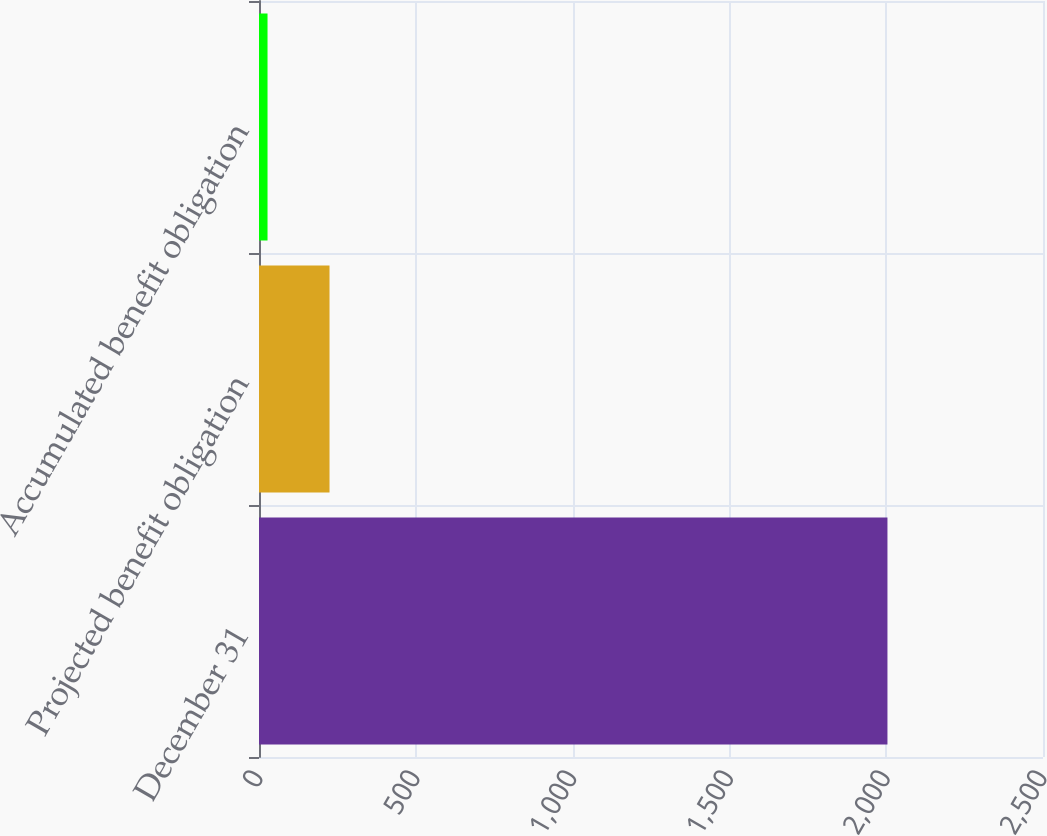<chart> <loc_0><loc_0><loc_500><loc_500><bar_chart><fcel>December 31<fcel>Projected benefit obligation<fcel>Accumulated benefit obligation<nl><fcel>2004<fcel>224.88<fcel>27.2<nl></chart> 